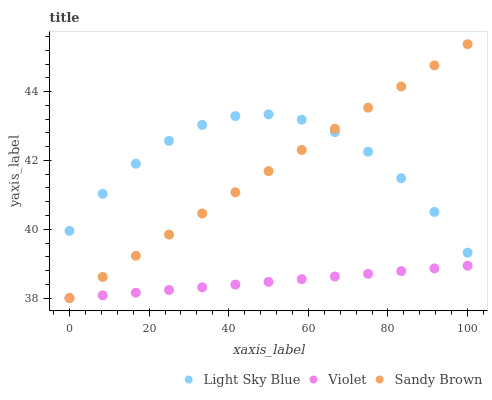Does Violet have the minimum area under the curve?
Answer yes or no. Yes. Does Light Sky Blue have the maximum area under the curve?
Answer yes or no. Yes. Does Sandy Brown have the minimum area under the curve?
Answer yes or no. No. Does Sandy Brown have the maximum area under the curve?
Answer yes or no. No. Is Violet the smoothest?
Answer yes or no. Yes. Is Light Sky Blue the roughest?
Answer yes or no. Yes. Is Sandy Brown the smoothest?
Answer yes or no. No. Is Sandy Brown the roughest?
Answer yes or no. No. Does Sandy Brown have the lowest value?
Answer yes or no. Yes. Does Sandy Brown have the highest value?
Answer yes or no. Yes. Does Violet have the highest value?
Answer yes or no. No. Is Violet less than Light Sky Blue?
Answer yes or no. Yes. Is Light Sky Blue greater than Violet?
Answer yes or no. Yes. Does Sandy Brown intersect Light Sky Blue?
Answer yes or no. Yes. Is Sandy Brown less than Light Sky Blue?
Answer yes or no. No. Is Sandy Brown greater than Light Sky Blue?
Answer yes or no. No. Does Violet intersect Light Sky Blue?
Answer yes or no. No. 